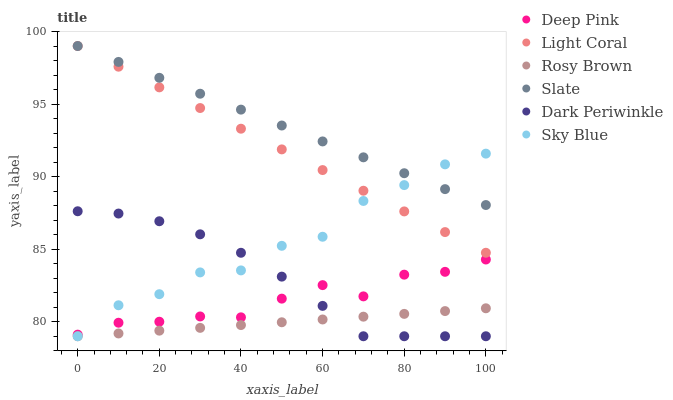Does Rosy Brown have the minimum area under the curve?
Answer yes or no. Yes. Does Slate have the maximum area under the curve?
Answer yes or no. Yes. Does Slate have the minimum area under the curve?
Answer yes or no. No. Does Rosy Brown have the maximum area under the curve?
Answer yes or no. No. Is Light Coral the smoothest?
Answer yes or no. Yes. Is Sky Blue the roughest?
Answer yes or no. Yes. Is Slate the smoothest?
Answer yes or no. No. Is Slate the roughest?
Answer yes or no. No. Does Rosy Brown have the lowest value?
Answer yes or no. Yes. Does Slate have the lowest value?
Answer yes or no. No. Does Light Coral have the highest value?
Answer yes or no. Yes. Does Rosy Brown have the highest value?
Answer yes or no. No. Is Rosy Brown less than Slate?
Answer yes or no. Yes. Is Slate greater than Deep Pink?
Answer yes or no. Yes. Does Sky Blue intersect Light Coral?
Answer yes or no. Yes. Is Sky Blue less than Light Coral?
Answer yes or no. No. Is Sky Blue greater than Light Coral?
Answer yes or no. No. Does Rosy Brown intersect Slate?
Answer yes or no. No. 